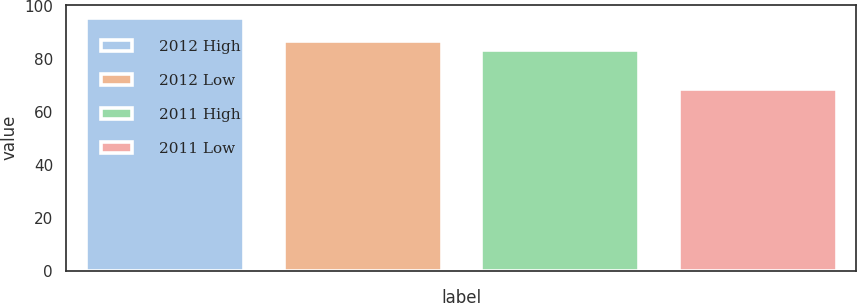<chart> <loc_0><loc_0><loc_500><loc_500><bar_chart><fcel>2012 High<fcel>2012 Low<fcel>2011 High<fcel>2011 Low<nl><fcel>95.46<fcel>86.74<fcel>83.1<fcel>68.63<nl></chart> 